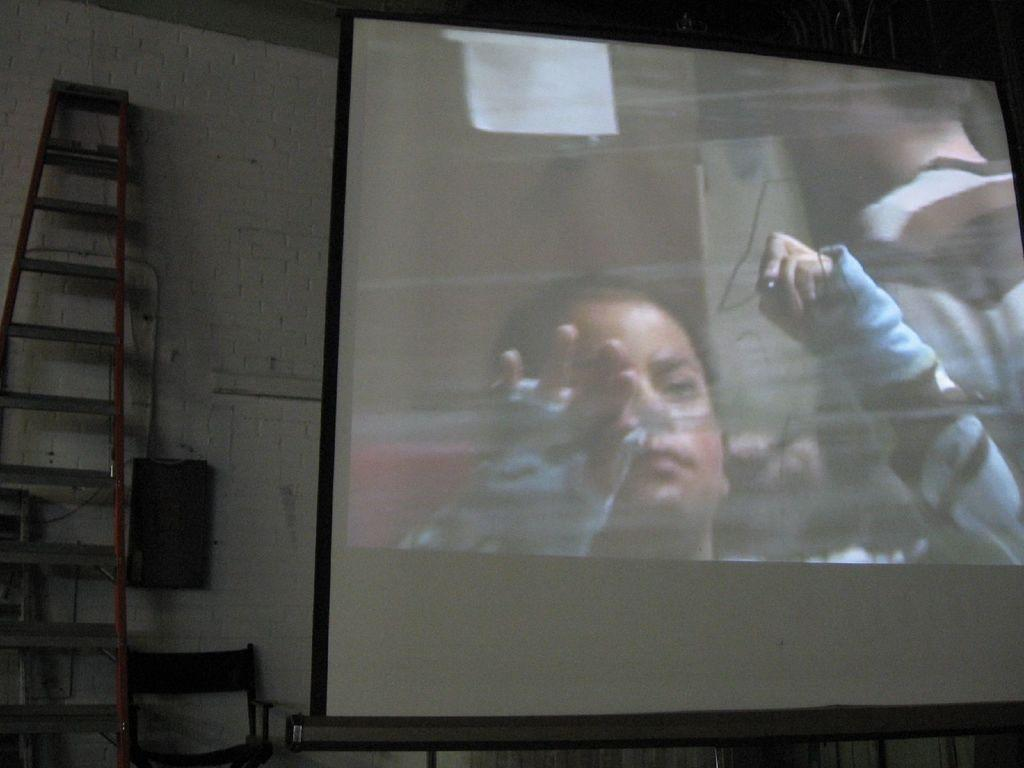What object is located on the left side of the image? There is a ladder on the left side of the image. What other object is also on the left side of the image? There is a chair on the left side of the image. Where is the speaker in the image? The speaker is on the wall in the image. What can be seen on the screen in the image? There is a screen with an image of a person in the image. Can you tell me how many times the person on the screen jumps in the image? There is no indication of the person on the screen jumping in the image. What type of screw is holding the ladder to the wall in the image? There is no screw visible in the image, and the ladder is not attached to the wall. 